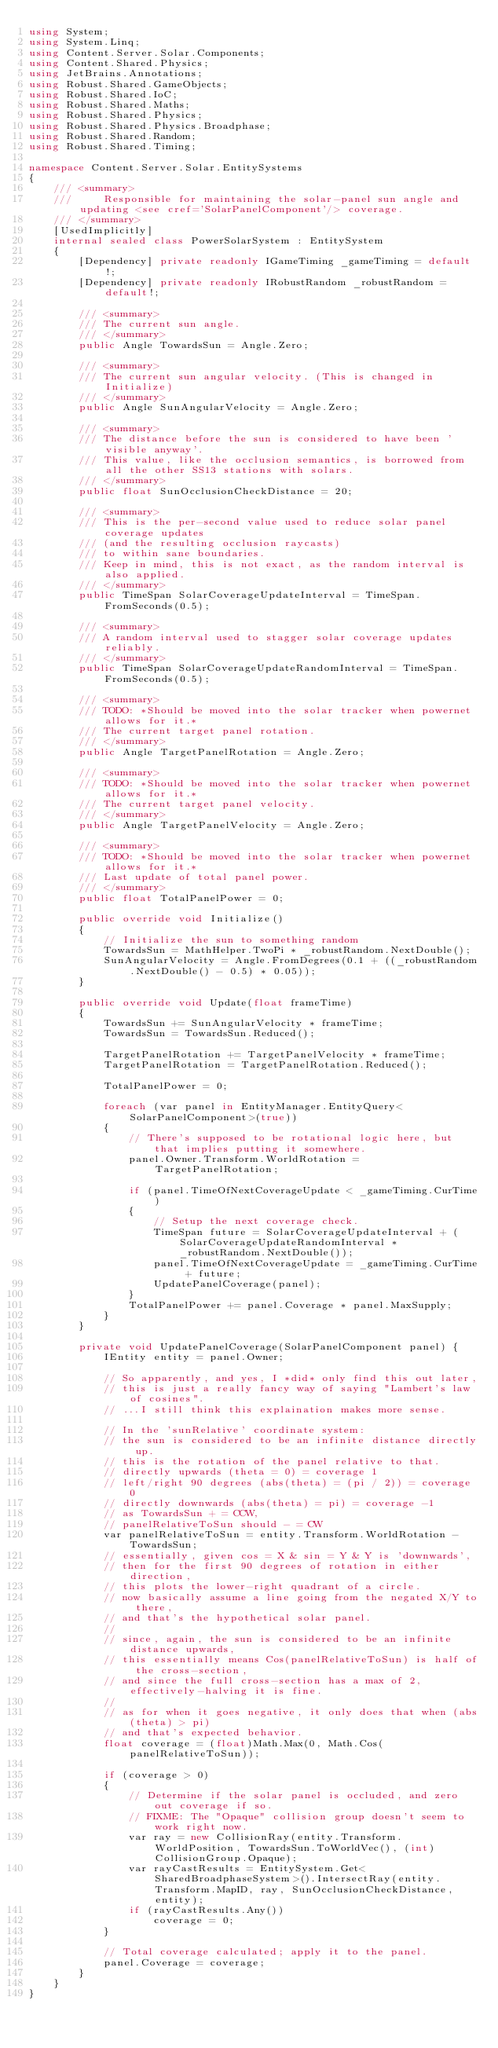Convert code to text. <code><loc_0><loc_0><loc_500><loc_500><_C#_>using System;
using System.Linq;
using Content.Server.Solar.Components;
using Content.Shared.Physics;
using JetBrains.Annotations;
using Robust.Shared.GameObjects;
using Robust.Shared.IoC;
using Robust.Shared.Maths;
using Robust.Shared.Physics;
using Robust.Shared.Physics.Broadphase;
using Robust.Shared.Random;
using Robust.Shared.Timing;

namespace Content.Server.Solar.EntitySystems
{
    /// <summary>
    ///     Responsible for maintaining the solar-panel sun angle and updating <see cref='SolarPanelComponent'/> coverage.
    /// </summary>
    [UsedImplicitly]
    internal sealed class PowerSolarSystem : EntitySystem
    {
        [Dependency] private readonly IGameTiming _gameTiming = default!;
        [Dependency] private readonly IRobustRandom _robustRandom = default!;

        /// <summary>
        /// The current sun angle.
        /// </summary>
        public Angle TowardsSun = Angle.Zero;

        /// <summary>
        /// The current sun angular velocity. (This is changed in Initialize)
        /// </summary>
        public Angle SunAngularVelocity = Angle.Zero;

        /// <summary>
        /// The distance before the sun is considered to have been 'visible anyway'.
        /// This value, like the occlusion semantics, is borrowed from all the other SS13 stations with solars.
        /// </summary>
        public float SunOcclusionCheckDistance = 20;

        /// <summary>
        /// This is the per-second value used to reduce solar panel coverage updates
        /// (and the resulting occlusion raycasts)
        /// to within sane boundaries.
        /// Keep in mind, this is not exact, as the random interval is also applied.
        /// </summary>
        public TimeSpan SolarCoverageUpdateInterval = TimeSpan.FromSeconds(0.5);

        /// <summary>
        /// A random interval used to stagger solar coverage updates reliably.
        /// </summary>
        public TimeSpan SolarCoverageUpdateRandomInterval = TimeSpan.FromSeconds(0.5);

        /// <summary>
        /// TODO: *Should be moved into the solar tracker when powernet allows for it.*
        /// The current target panel rotation.
        /// </summary>
        public Angle TargetPanelRotation = Angle.Zero;

        /// <summary>
        /// TODO: *Should be moved into the solar tracker when powernet allows for it.*
        /// The current target panel velocity.
        /// </summary>
        public Angle TargetPanelVelocity = Angle.Zero;

        /// <summary>
        /// TODO: *Should be moved into the solar tracker when powernet allows for it.*
        /// Last update of total panel power.
        /// </summary>
        public float TotalPanelPower = 0;

        public override void Initialize()
        {
            // Initialize the sun to something random
            TowardsSun = MathHelper.TwoPi * _robustRandom.NextDouble();
            SunAngularVelocity = Angle.FromDegrees(0.1 + ((_robustRandom.NextDouble() - 0.5) * 0.05));
        }

        public override void Update(float frameTime)
        {
            TowardsSun += SunAngularVelocity * frameTime;
            TowardsSun = TowardsSun.Reduced();

            TargetPanelRotation += TargetPanelVelocity * frameTime;
            TargetPanelRotation = TargetPanelRotation.Reduced();

            TotalPanelPower = 0;

            foreach (var panel in EntityManager.EntityQuery<SolarPanelComponent>(true))
            {
                // There's supposed to be rotational logic here, but that implies putting it somewhere.
                panel.Owner.Transform.WorldRotation = TargetPanelRotation;

                if (panel.TimeOfNextCoverageUpdate < _gameTiming.CurTime)
                {
                    // Setup the next coverage check.
                    TimeSpan future = SolarCoverageUpdateInterval + (SolarCoverageUpdateRandomInterval * _robustRandom.NextDouble());
                    panel.TimeOfNextCoverageUpdate = _gameTiming.CurTime + future;
                    UpdatePanelCoverage(panel);
                }
                TotalPanelPower += panel.Coverage * panel.MaxSupply;
            }
        }

        private void UpdatePanelCoverage(SolarPanelComponent panel) {
            IEntity entity = panel.Owner;

            // So apparently, and yes, I *did* only find this out later,
            // this is just a really fancy way of saying "Lambert's law of cosines".
            // ...I still think this explaination makes more sense.

            // In the 'sunRelative' coordinate system:
            // the sun is considered to be an infinite distance directly up.
            // this is the rotation of the panel relative to that.
            // directly upwards (theta = 0) = coverage 1
            // left/right 90 degrees (abs(theta) = (pi / 2)) = coverage 0
            // directly downwards (abs(theta) = pi) = coverage -1
            // as TowardsSun + = CCW,
            // panelRelativeToSun should - = CW
            var panelRelativeToSun = entity.Transform.WorldRotation - TowardsSun;
            // essentially, given cos = X & sin = Y & Y is 'downwards',
            // then for the first 90 degrees of rotation in either direction,
            // this plots the lower-right quadrant of a circle.
            // now basically assume a line going from the negated X/Y to there,
            // and that's the hypothetical solar panel.
            //
            // since, again, the sun is considered to be an infinite distance upwards,
            // this essentially means Cos(panelRelativeToSun) is half of the cross-section,
            // and since the full cross-section has a max of 2, effectively-halving it is fine.
            //
            // as for when it goes negative, it only does that when (abs(theta) > pi)
            // and that's expected behavior.
            float coverage = (float)Math.Max(0, Math.Cos(panelRelativeToSun));

            if (coverage > 0)
            {
                // Determine if the solar panel is occluded, and zero out coverage if so.
                // FIXME: The "Opaque" collision group doesn't seem to work right now.
                var ray = new CollisionRay(entity.Transform.WorldPosition, TowardsSun.ToWorldVec(), (int) CollisionGroup.Opaque);
                var rayCastResults = EntitySystem.Get<SharedBroadphaseSystem>().IntersectRay(entity.Transform.MapID, ray, SunOcclusionCheckDistance, entity);
                if (rayCastResults.Any())
                    coverage = 0;
            }

            // Total coverage calculated; apply it to the panel.
            panel.Coverage = coverage;
        }
    }
}
</code> 